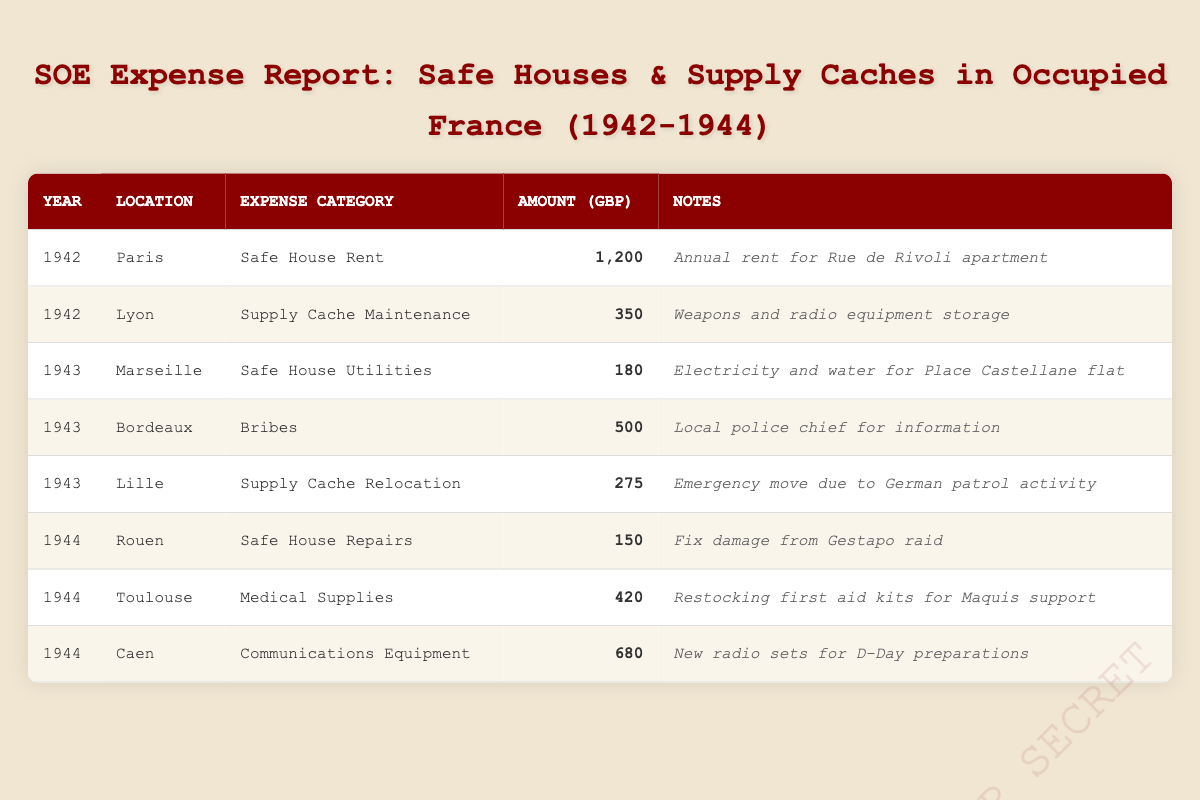What is the total amount spent on safe house rent in Paris in 1942? In the table, the amount spent on safe house rent in Paris for the year 1942 is listed as 1,200 GBP. Since there's only one entry for that expense category and location in that year, the total is simply 1,200 GBP.
Answer: 1,200 GBP How much was spent on medical supplies in Toulouse in 1944? The table shows that the amount spent on medical supplies in Toulouse in 1944 is listed as 420 GBP. There are no other entries in the table that concern this specific expense category for that location and year.
Answer: 420 GBP Were bribes paid in Bordeaux? Yes, according to the table, there is an entry for "Bribes" in Bordeaux for 1943 with an amount of 500 GBP. This confirms that bribes were indeed paid in that location.
Answer: Yes What is the average amount spent on supply cache maintenance across all locations? The table lists only one entry for supply cache maintenance, which is 350 GBP in Lyon for 1942. Since there are no other entries for that category, the average is simply 350 GBP divided by 1, which equals 350 GBP.
Answer: 350 GBP How much was spent in total across all categories in 1944? To find the total for 1944, we sum up the amounts for all entries in that year: 150 (safe house repairs in Rouen) + 420 (medical supplies in Toulouse) + 680 (communications equipment in Caen) = 1,250 GBP. Thus, the total amount spent in 1944 is 1,250 GBP.
Answer: 1,250 GBP Which year saw the highest single expense for safe house-related costs? In 1942, the single highest expense related to safe houses was 1,200 GBP for safe house rent in Paris. In 1943 and 1944, none of the safe house related expenses exceeded this amount. Therefore, 1942 has the highest single expense.
Answer: 1942 What was the least amount spent on an expense category listed in the table? The least amount spent is 150 GBP, which was for safe house repairs in Rouen in 1944. This is the smallest numerical value present in the table among all recorded expenses.
Answer: 150 GBP How many entries pertain to safe house utilities? The table shows one entry specifically categorized as safe house utilities, which is listed for Marseille in 1943 with the amount of 180 GBP. Thus, there is only one entry for that category.
Answer: 1 